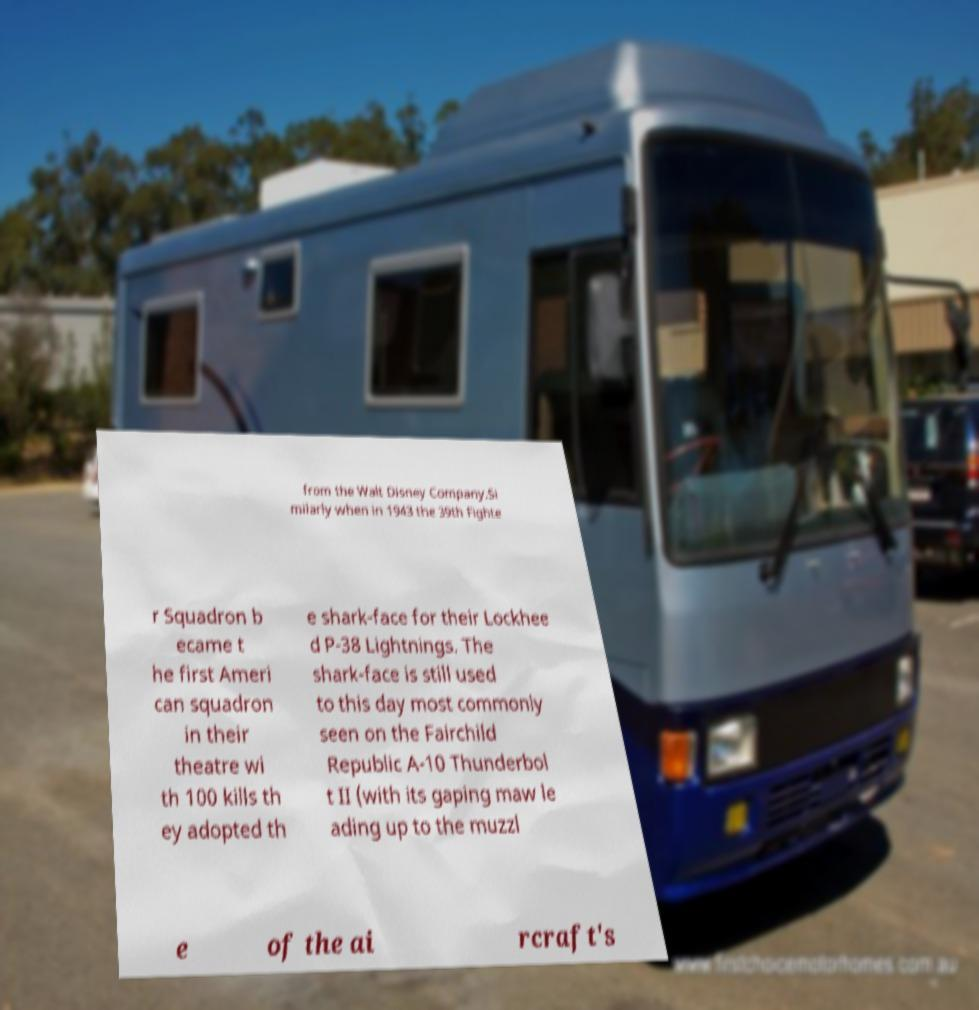Can you accurately transcribe the text from the provided image for me? from the Walt Disney Company.Si milarly when in 1943 the 39th Fighte r Squadron b ecame t he first Ameri can squadron in their theatre wi th 100 kills th ey adopted th e shark-face for their Lockhee d P-38 Lightnings. The shark-face is still used to this day most commonly seen on the Fairchild Republic A-10 Thunderbol t II (with its gaping maw le ading up to the muzzl e of the ai rcraft's 